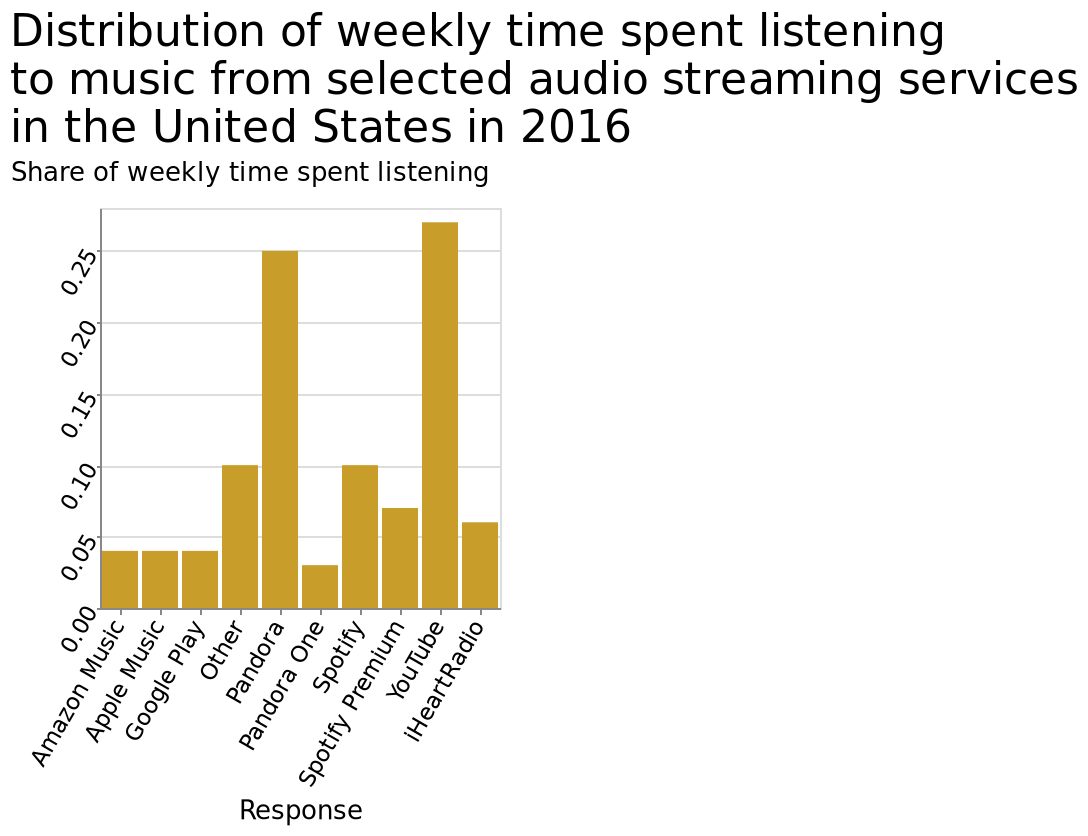<image>
Describe the following image in detail This bar plot is labeled Distribution of weekly time spent listening to music from selected audio streaming services in the United States in 2016. Along the y-axis, Share of weekly time spent listening is plotted along a linear scale with a minimum of 0.00 and a maximum of 0.25. The x-axis plots Response with a categorical scale with Amazon Music on one end and iHeartRadio at the other. What were the two platforms with the highest proportion of streamers in the USA in 2016?  YouTube and Pandora. please summary the statistics and relations of the chart YouTube and Pandora share similar levels of monopoly of the time spend using their service at above 0.25 and 0.25 respectively. Other services and Spotify were the next most used, but only at 0.10. 